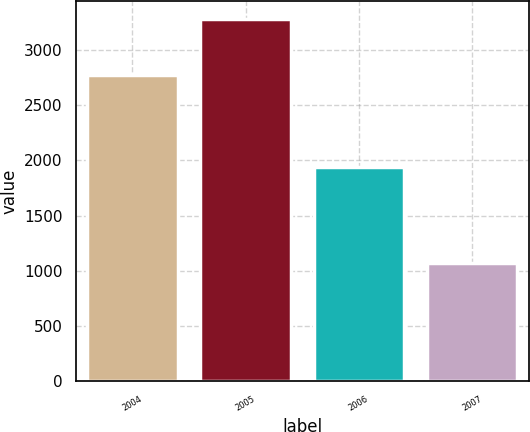Convert chart. <chart><loc_0><loc_0><loc_500><loc_500><bar_chart><fcel>2004<fcel>2005<fcel>2006<fcel>2007<nl><fcel>2775<fcel>3281<fcel>1939<fcel>1075<nl></chart> 